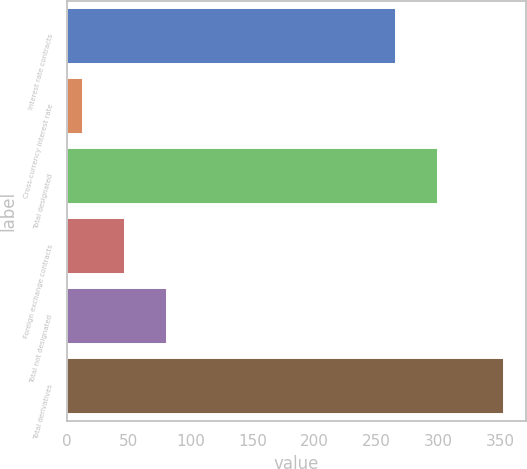Convert chart. <chart><loc_0><loc_0><loc_500><loc_500><bar_chart><fcel>Interest rate contracts<fcel>Cross-currency interest rate<fcel>Total designated<fcel>Foreign exchange contracts<fcel>Total not designated<fcel>Total derivatives<nl><fcel>266<fcel>13<fcel>300<fcel>47<fcel>81<fcel>353<nl></chart> 